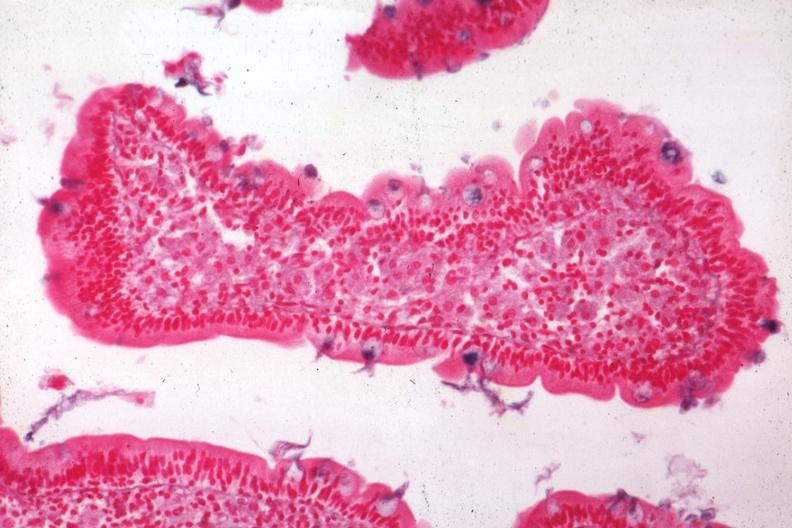what does this image show?
Answer the question using a single word or phrase. Med alcian blue with apparently eosin counterstain enlarged villus with many macrophages source 